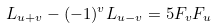<formula> <loc_0><loc_0><loc_500><loc_500>L _ { u + v } - ( - 1 ) ^ { v } L _ { u - v } = 5 F _ { v } F _ { u }</formula> 